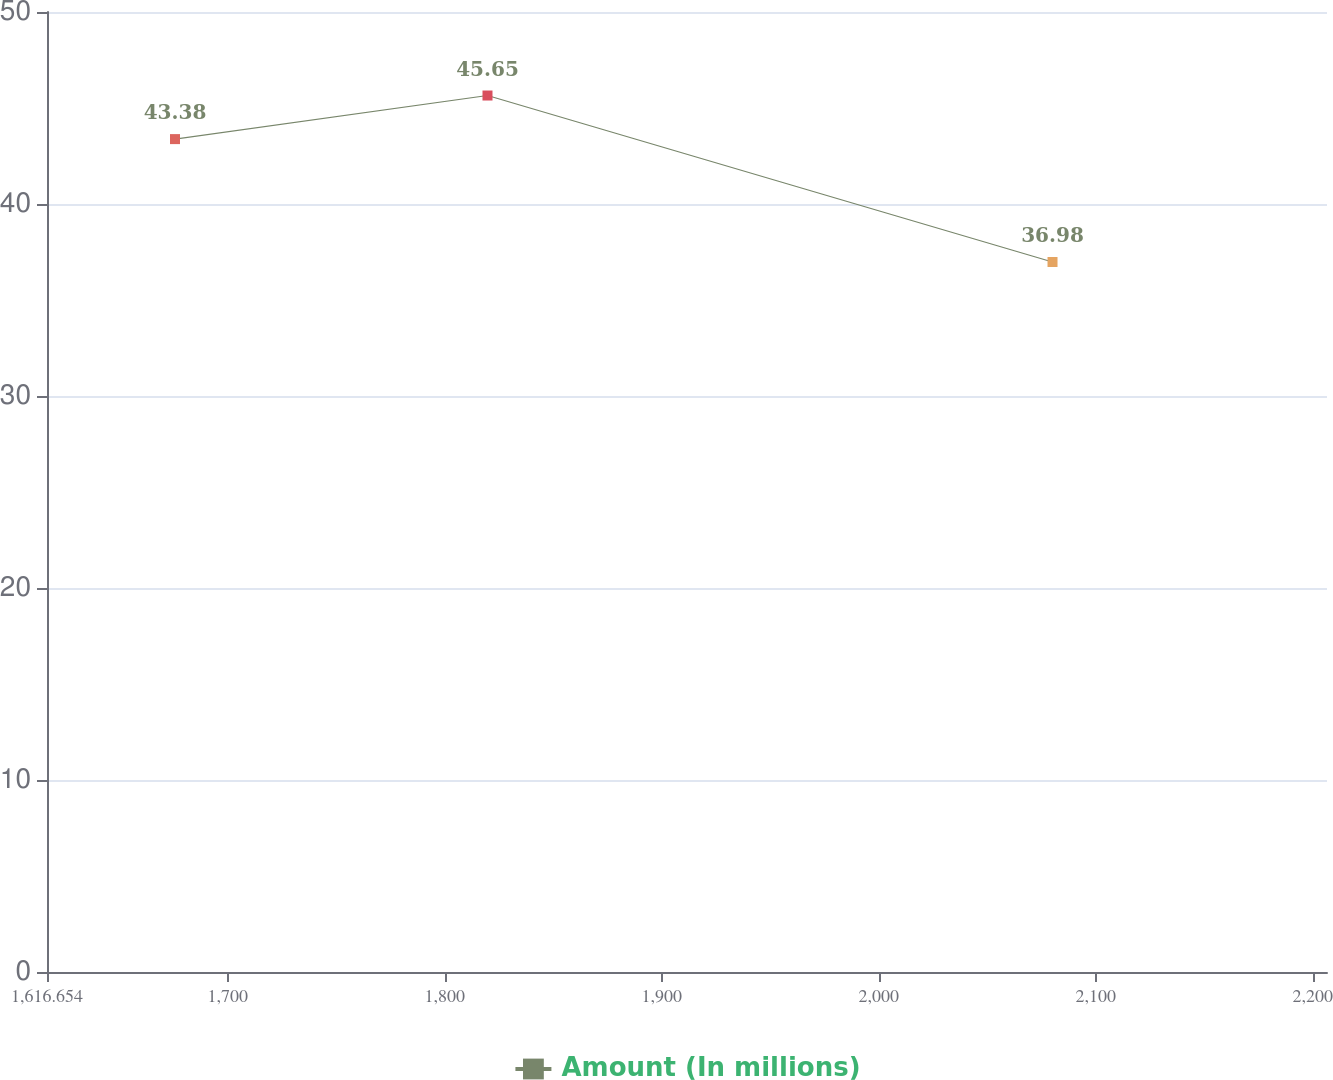Convert chart. <chart><loc_0><loc_0><loc_500><loc_500><line_chart><ecel><fcel>Amount (In millions)<nl><fcel>1675.65<fcel>43.38<nl><fcel>1819.68<fcel>45.65<nl><fcel>2080.1<fcel>36.98<nl><fcel>2208.93<fcel>26<nl><fcel>2265.61<fcel>21.3<nl></chart> 